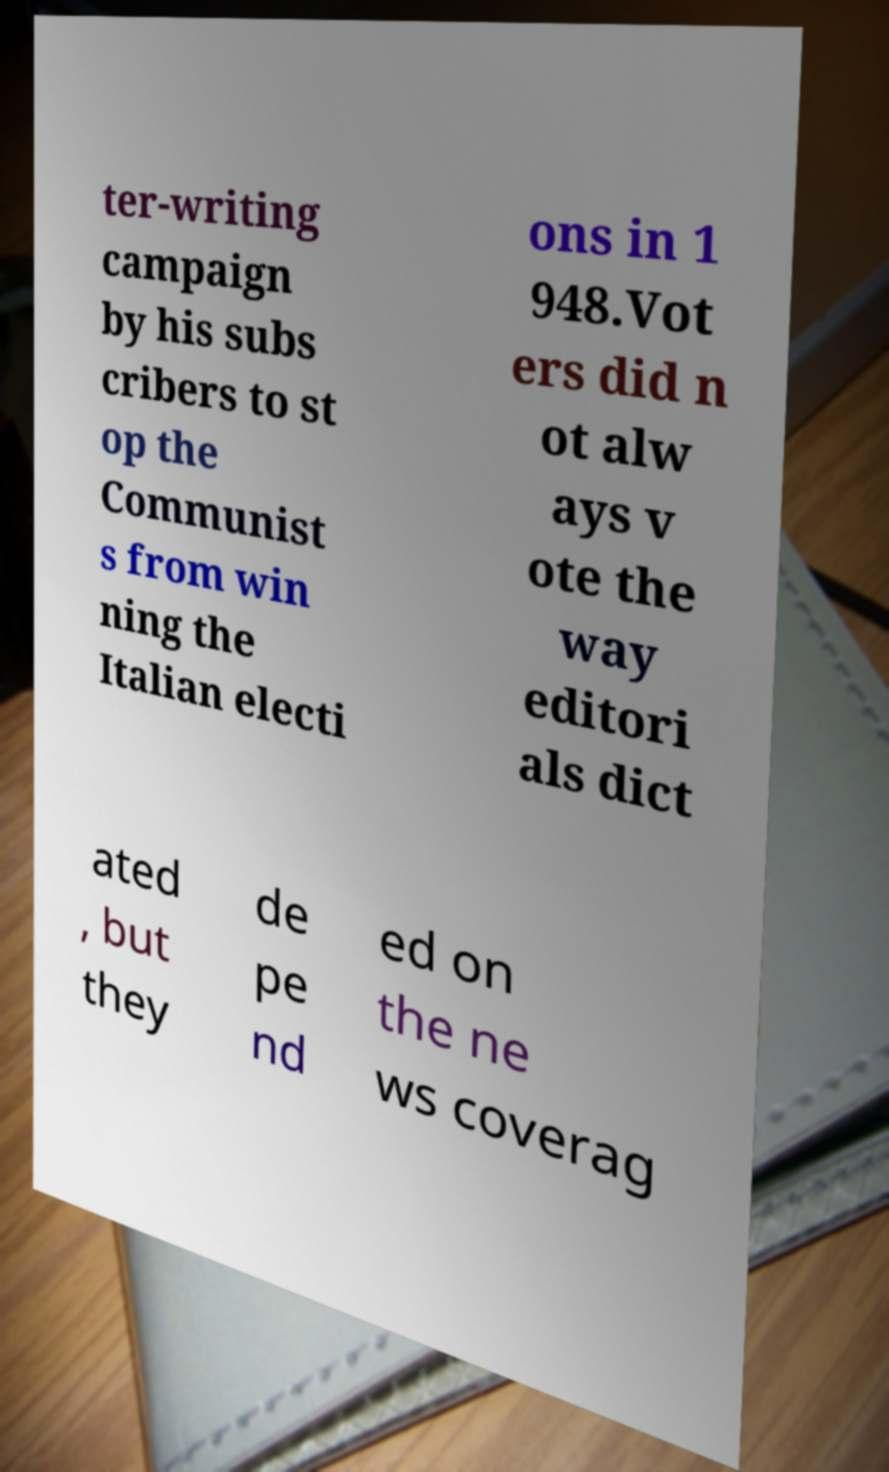Please identify and transcribe the text found in this image. ter-writing campaign by his subs cribers to st op the Communist s from win ning the Italian electi ons in 1 948.Vot ers did n ot alw ays v ote the way editori als dict ated , but they de pe nd ed on the ne ws coverag 